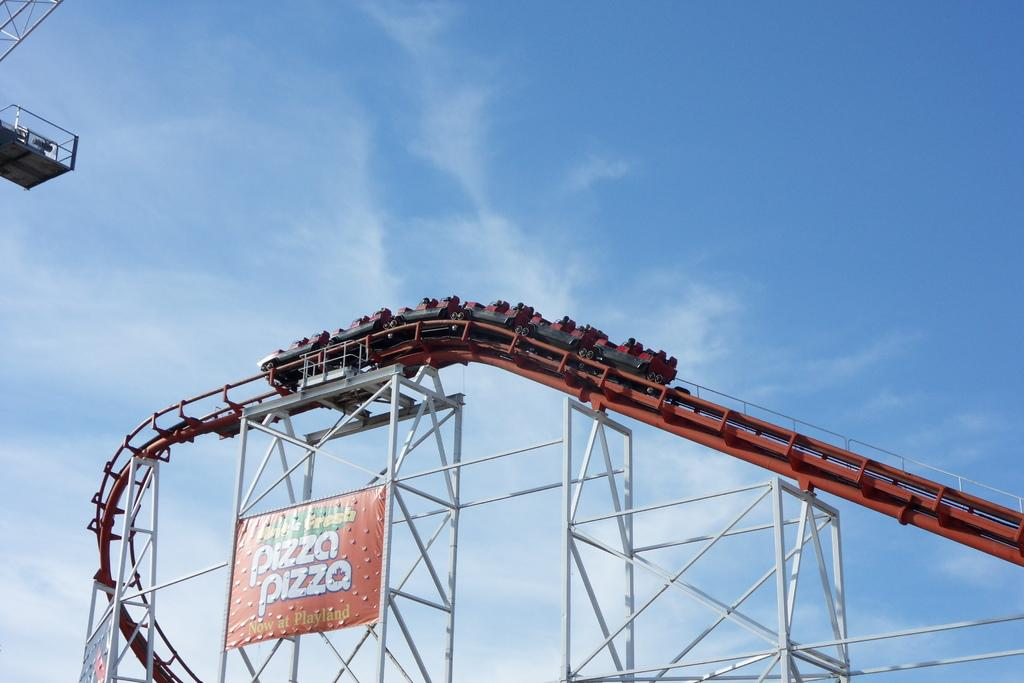Provide a one-sentence caption for the provided image. A red rollercoaster with a banner attached to it advertising Fresh Pizza available now at Playland. 